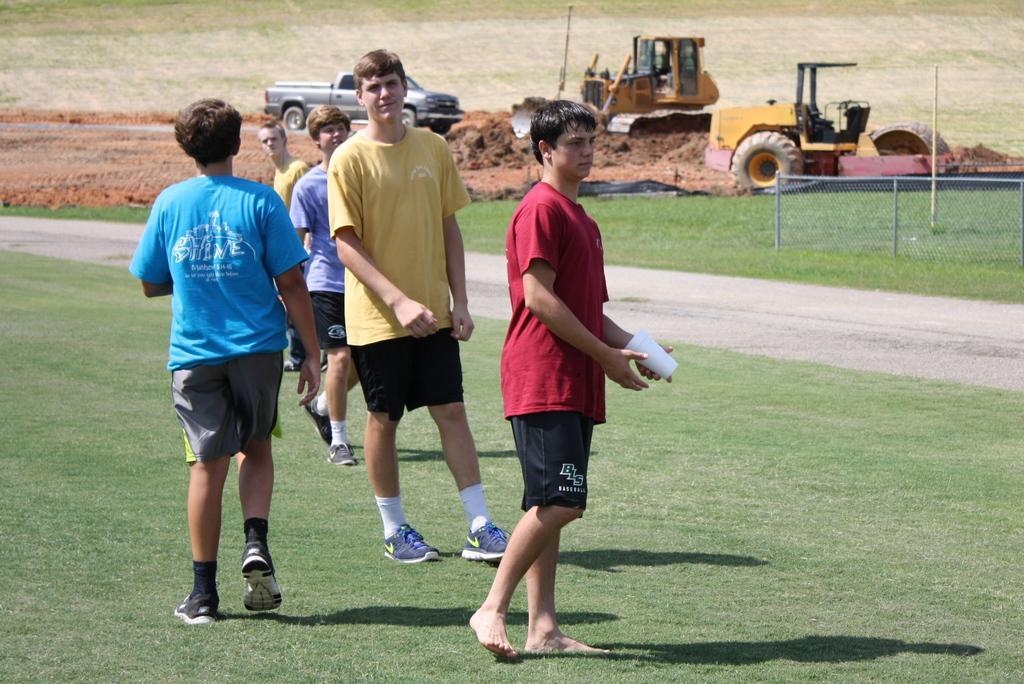Can you describe this image briefly? In this image we can see a few people standing on the ground, among them one is holding an object, in the background, we can see some vehicles, sand, poles and fence. 